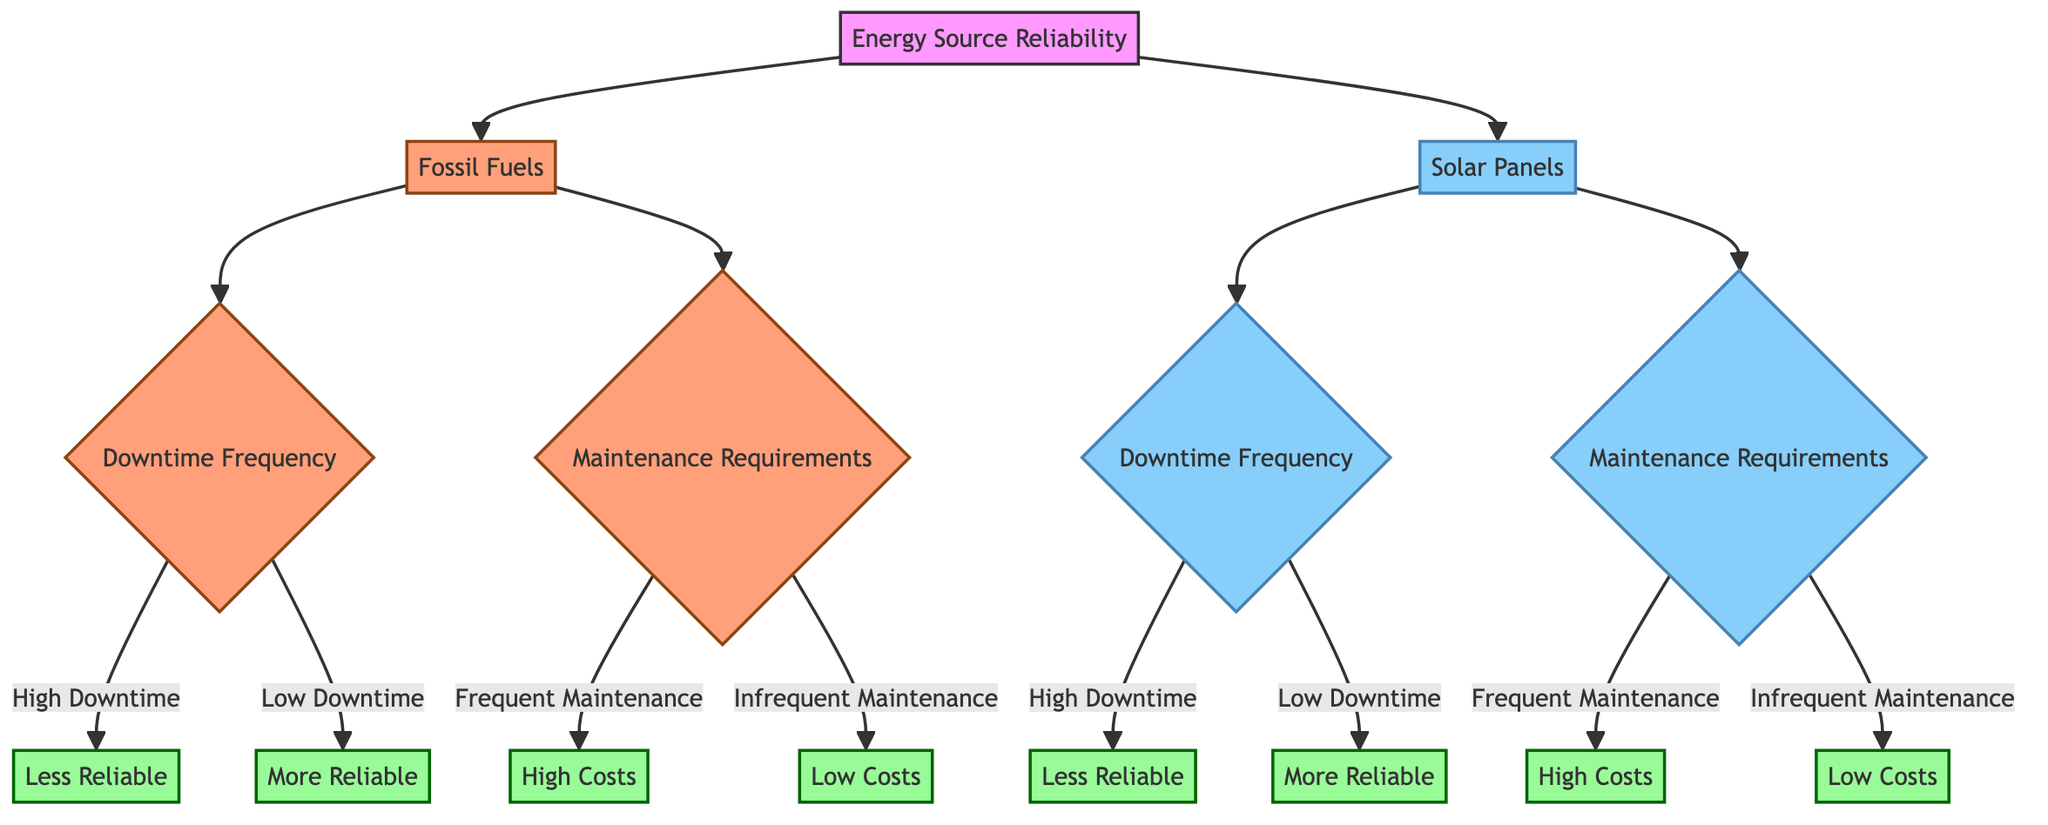What are the two main branches of the decision tree? The diagram displays two main branches originating from the root: Fossil Fuels and Solar Panels.
Answer: Fossil Fuels, Solar Panels What is the result of high downtime for fossil fuels? According to the tree, if fossil fuels experience high downtime, they are classified as "Less Reliable."
Answer: Less Reliable What are the maintenance requirements outcomes for solar panels? The diagram outlines two outcomes for solar panels under maintenance requirements: "High Costs" for frequent maintenance and "Low Costs" for infrequent maintenance.
Answer: High Costs, Low Costs Which energy source shows "More Reliable" for low downtime? Both fossil fuels and solar panels yield "More Reliable" when downtime is low, indicating that this condition applies universally to both sources in the decision tree.
Answer: More Reliable If a fossil fuel source has infrequent maintenance, what would the result be? The decision tree states that infrequent maintenance leads to "Low Costs" for fossil fuels, making it financially advantageous.
Answer: Low Costs What is the maximum number of outcomes listed under each energy source for downtime frequency? Each energy source has two possible outcomes for downtime frequency according to the diagram: "High Downtime" and "Low Downtime." Therefore, the total number of outcomes per energy source is two.
Answer: Two How many total criteria are evaluated in this decision tree? The decision tree evaluates a total of four criteria: Downtime Frequency and Maintenance Requirements for both Fossil Fuels and Solar Panels, summing up to four distinct criteria.
Answer: Four What costs are associated with frequent maintenance for solar panels? The outcome for solar panels under the condition of frequent maintenance indicates "High Costs," highlighting a significant financial implication.
Answer: High Costs What does low downtime for solar panels signify? The diagram states that low downtime signifies "More Reliable" for solar panels, suggesting better operational performance under this condition.
Answer: More Reliable 